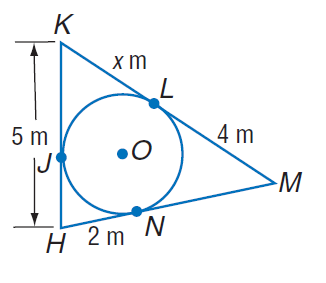Question: Find x. Assume that segments that appear to be tangent are tangent.
Choices:
A. 3
B. 4
C. 5
D. 6
Answer with the letter. Answer: A 